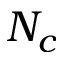Convert formula to latex. <formula><loc_0><loc_0><loc_500><loc_500>N _ { c }</formula> 